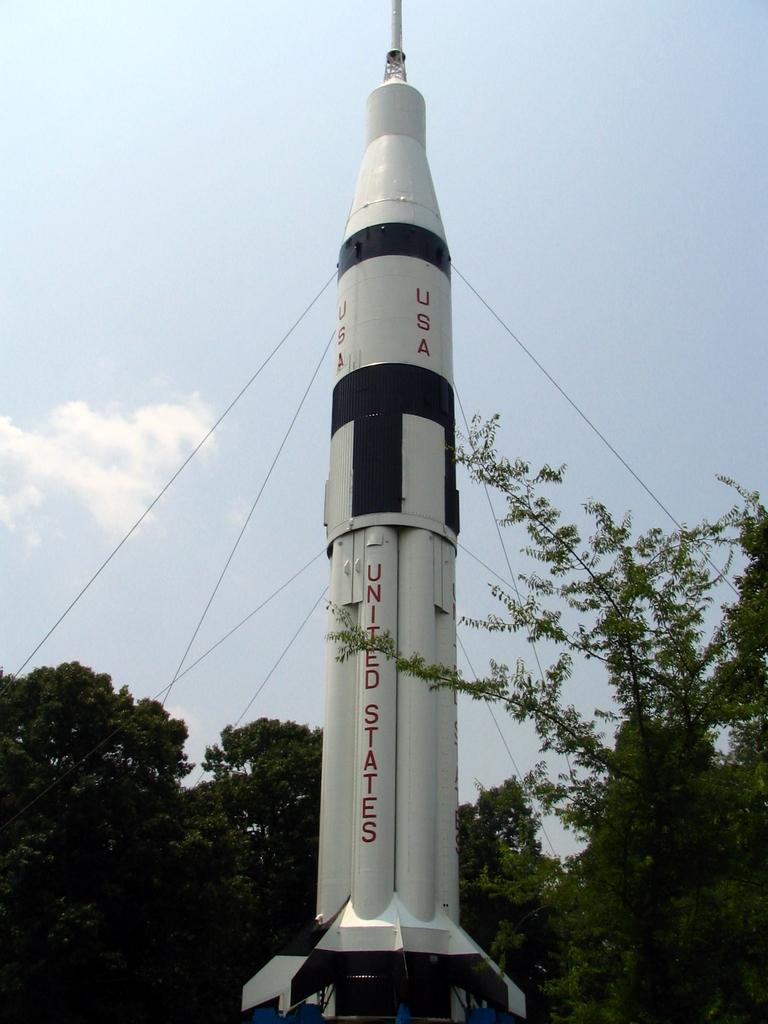What is the main subject of the image? There is a rocket in the image. What else can be seen in the image besides the rocket? There are trees and the sky visible in the image. Can you describe the rocket in more detail? The rocket has writing on it. What type of eggnog is being served in the image? There is no eggnog present in the image; it features a rocket, trees, and the sky. Who is the partner of the rocket in the image? There is no partner mentioned or depicted in the image; it only shows a rocket, trees, and the sky. 